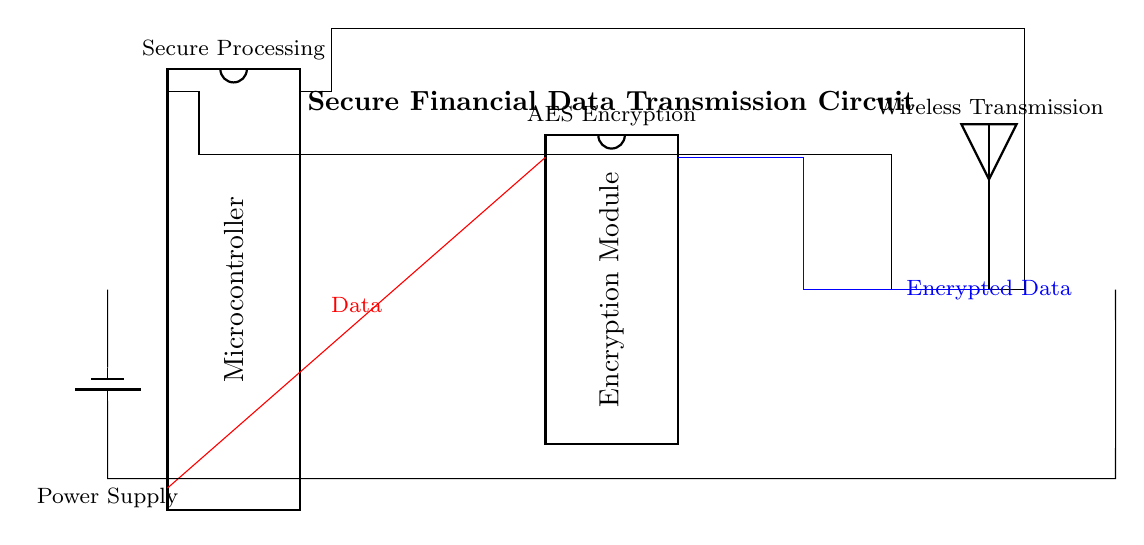What is the primary function of the encryption module? The primary function of the encryption module is to secure the financial data by encrypting it using a standard encryption algorithm like AES.
Answer: Encrypt data What is the type of the power supply in the circuit? The power supply in this circuit is represented by a battery component, which provides the necessary voltage for operation.
Answer: Battery Which component is responsible for wireless transmission of data? The antenna component is responsible for the wireless transmission of the encrypted data to ensure secure communication.
Answer: Antenna How does the data flow from the microcontroller to the encryption module? The data flows through a direct wire connection from pin 10 of the microcontroller to pin 1 of the encryption module, indicating a specific path for data transfer.
Answer: Direct connection What encryption standard is most likely used in the encryption module? The encryption module is labeled with "AES Encryption," suggesting that the Advanced Encryption Standard is the likely encryption standard utilized for securing sensitive information.
Answer: AES How many pins does the microcontroller have in this circuit? The microcontroller is specified to have 20 pins in total, which allow for various connections to other components in the circuit.
Answer: Twenty pins What is the role of the microcontroller in this circuit? The microcontroller serves as the secure processing unit, coordinating the data input, encryption, and transmission processes within the circuit.
Answer: Secure processing 